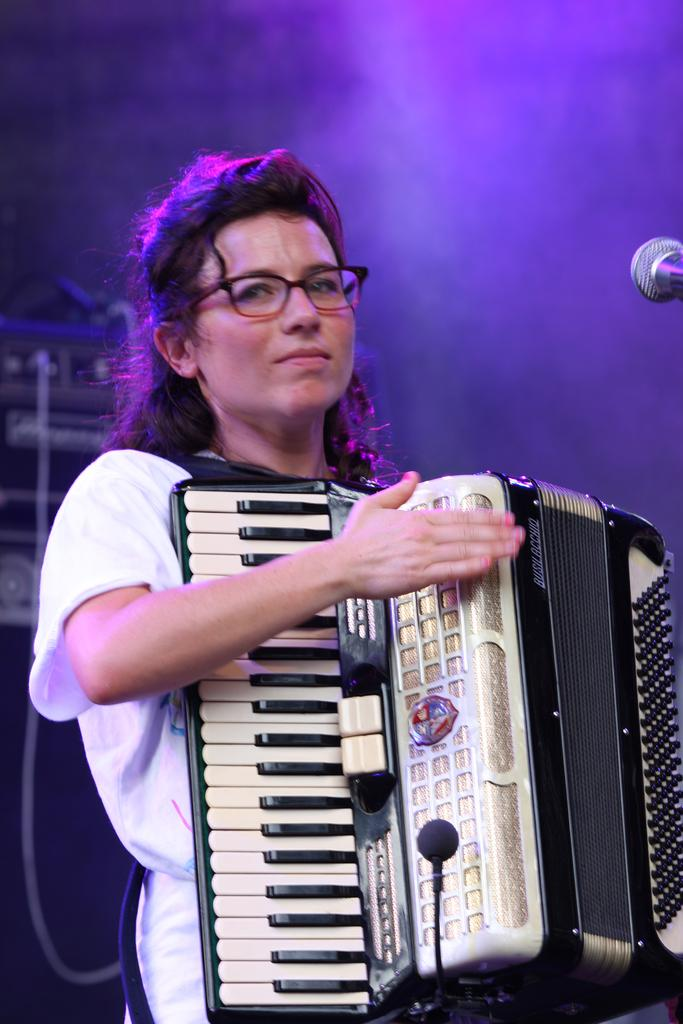Who is the main subject in the image? There is a woman in the center of the image. What is the woman holding in the image? The woman is holding a Garmin device. What can be seen on the right side of the image? There is a microphone on the right side of the image. What is present in the background of the image? There is a musical instrument and smoke visible in the background. How does the woman express her anger in the image? There is no indication of anger in the image; the woman is simply holding a Garmin device and standing near a microphone. 